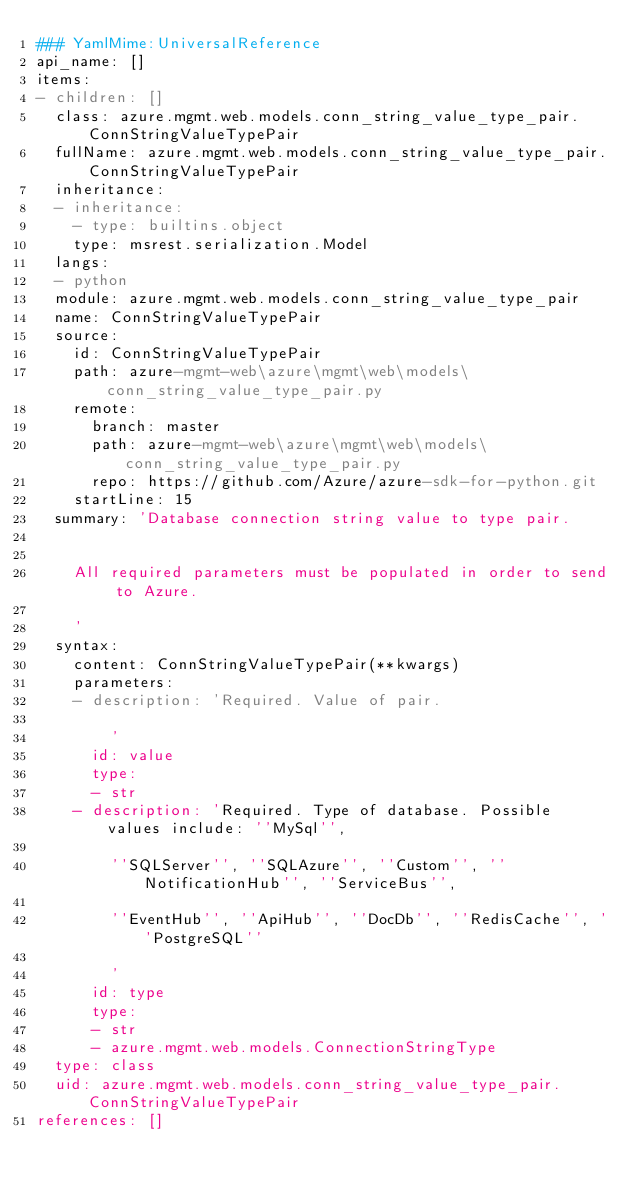<code> <loc_0><loc_0><loc_500><loc_500><_YAML_>### YamlMime:UniversalReference
api_name: []
items:
- children: []
  class: azure.mgmt.web.models.conn_string_value_type_pair.ConnStringValueTypePair
  fullName: azure.mgmt.web.models.conn_string_value_type_pair.ConnStringValueTypePair
  inheritance:
  - inheritance:
    - type: builtins.object
    type: msrest.serialization.Model
  langs:
  - python
  module: azure.mgmt.web.models.conn_string_value_type_pair
  name: ConnStringValueTypePair
  source:
    id: ConnStringValueTypePair
    path: azure-mgmt-web\azure\mgmt\web\models\conn_string_value_type_pair.py
    remote:
      branch: master
      path: azure-mgmt-web\azure\mgmt\web\models\conn_string_value_type_pair.py
      repo: https://github.com/Azure/azure-sdk-for-python.git
    startLine: 15
  summary: 'Database connection string value to type pair.


    All required parameters must be populated in order to send to Azure.

    '
  syntax:
    content: ConnStringValueTypePair(**kwargs)
    parameters:
    - description: 'Required. Value of pair.

        '
      id: value
      type:
      - str
    - description: 'Required. Type of database. Possible values include: ''MySql'',

        ''SQLServer'', ''SQLAzure'', ''Custom'', ''NotificationHub'', ''ServiceBus'',

        ''EventHub'', ''ApiHub'', ''DocDb'', ''RedisCache'', ''PostgreSQL''

        '
      id: type
      type:
      - str
      - azure.mgmt.web.models.ConnectionStringType
  type: class
  uid: azure.mgmt.web.models.conn_string_value_type_pair.ConnStringValueTypePair
references: []
</code> 